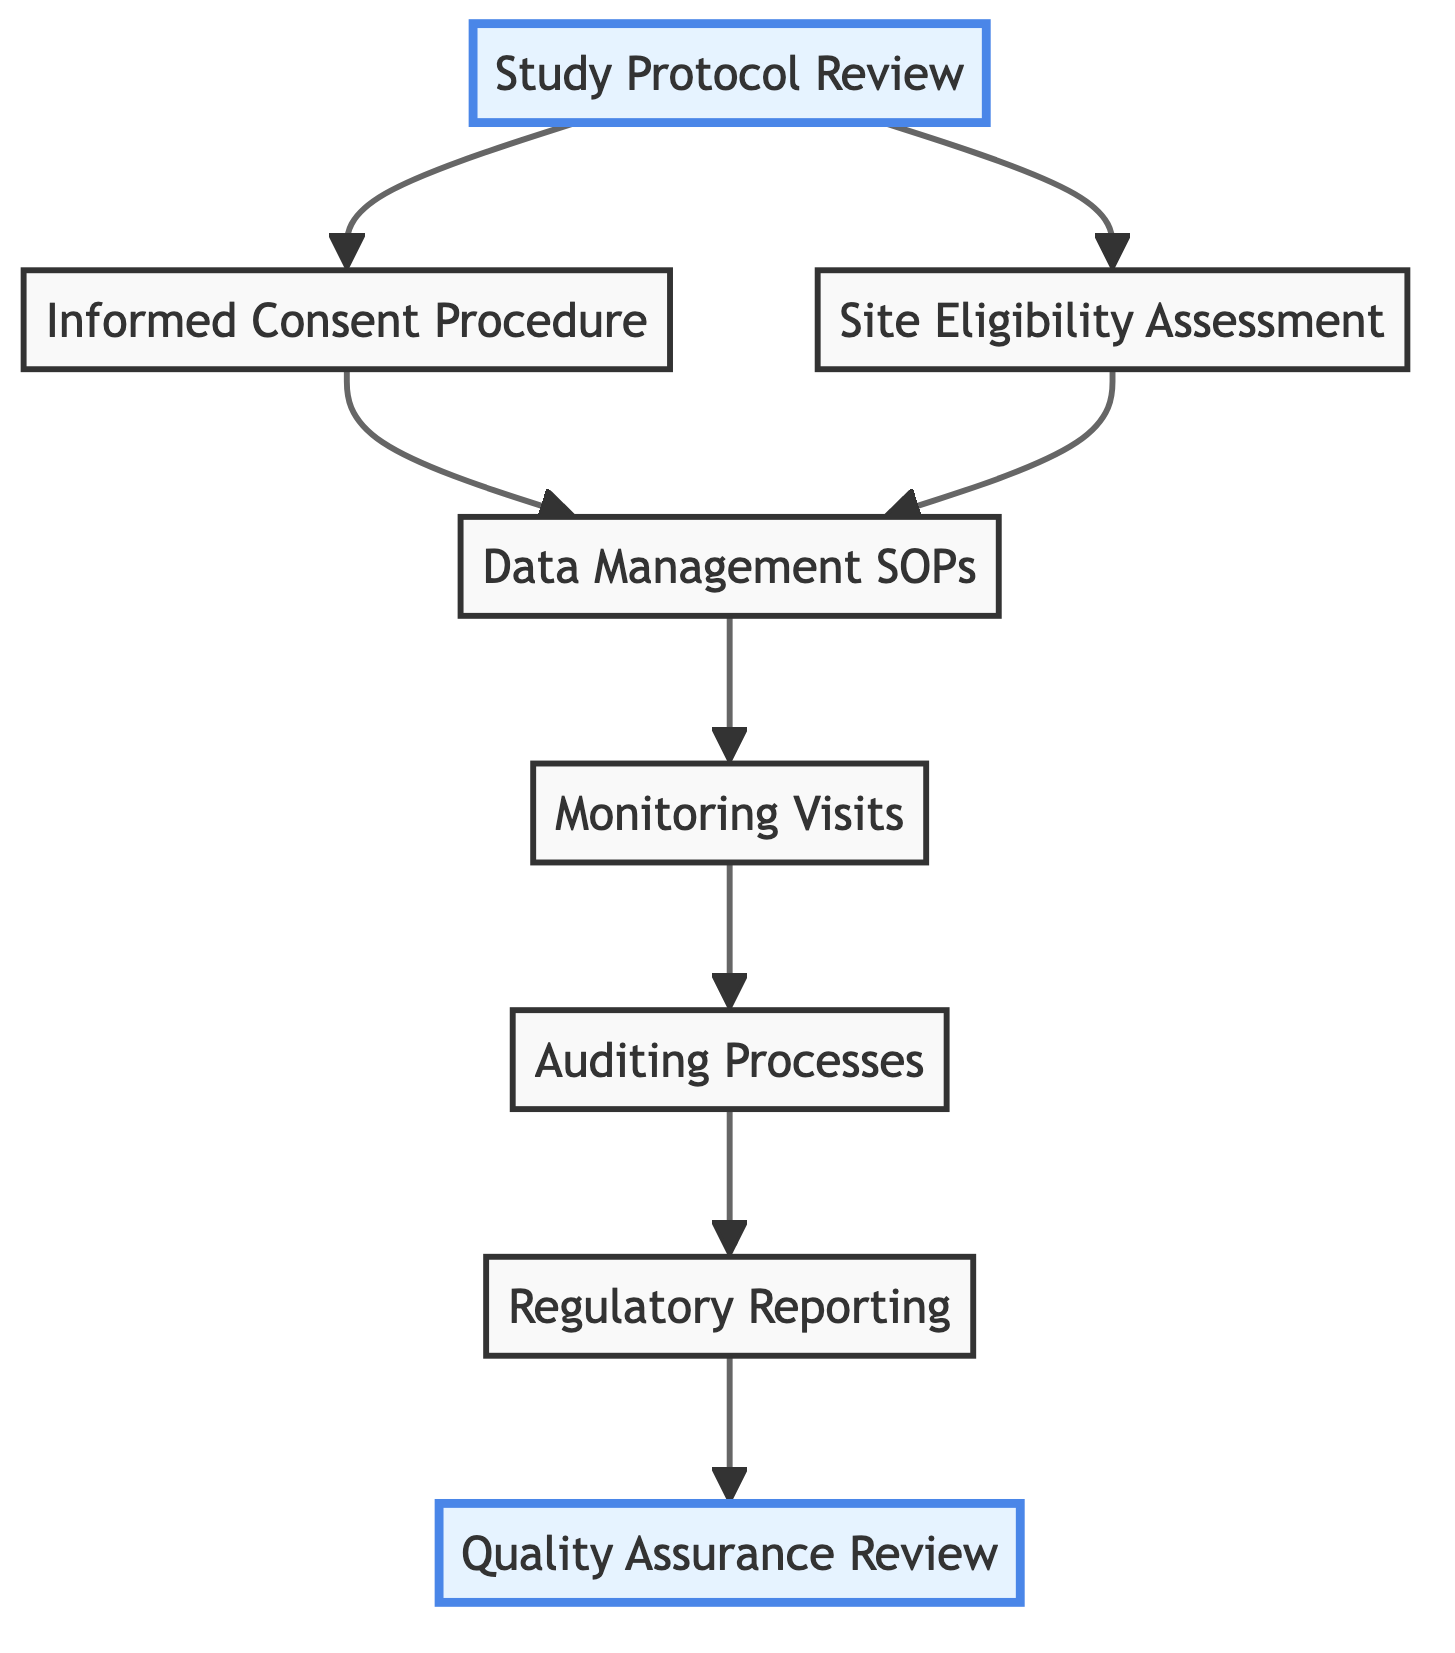What is the first step in the clinical research quality control process? The first step in the process is represented by the node "Study Protocol Review", which indicates the initial evaluation of the clinical trial protocol for compliance with regulatory requirements.
Answer: Study Protocol Review How many nodes are in the diagram? The diagram includes eight nodes, representing various quality control measures and checkpoints in the clinical research process.
Answer: 8 Which nodes are highlighted in the diagram? The nodes "Study Protocol Review" and "Quality Assurance Review" are highlighted, indicating their significance in the process.
Answer: Study Protocol Review, Quality Assurance Review What is the relationship between "Monitoring Visits" and "Auditing Processes"? "Monitoring Visits" directly leads to "Auditing Processes" in the diagram, indicating that monitoring feeds into the auditing process as a subsequent step.
Answer: Monitoring Visits → Auditing Processes What comes after "Regulatory Reporting" in the process? The next step following "Regulatory Reporting" is "Quality Assurance Review", which serves as a final review of all processes and data to ensure compliance.
Answer: Quality Assurance Review Which node is the last step in the quality control process? The last step in the quality control process is "Quality Assurance Review", which ensures compliance before final reporting.
Answer: Quality Assurance Review Which processes lead to "Data Management SOPs"? Both "Informed Consent Procedure" and "Site Eligibility Assessment" lead to "Data Management SOPs", indicating that these processes contribute to establishing SOPs for data handling.
Answer: Informed Consent Procedure, Site Eligibility Assessment How does "Site Eligibility Assessment" relate to "Informed Consent Procedure"? "Site Eligibility Assessment" and "Informed Consent Procedure" both stem from "Study Protocol Review", indicating they are parallel steps following the initial review.
Answer: They are parallel steps 